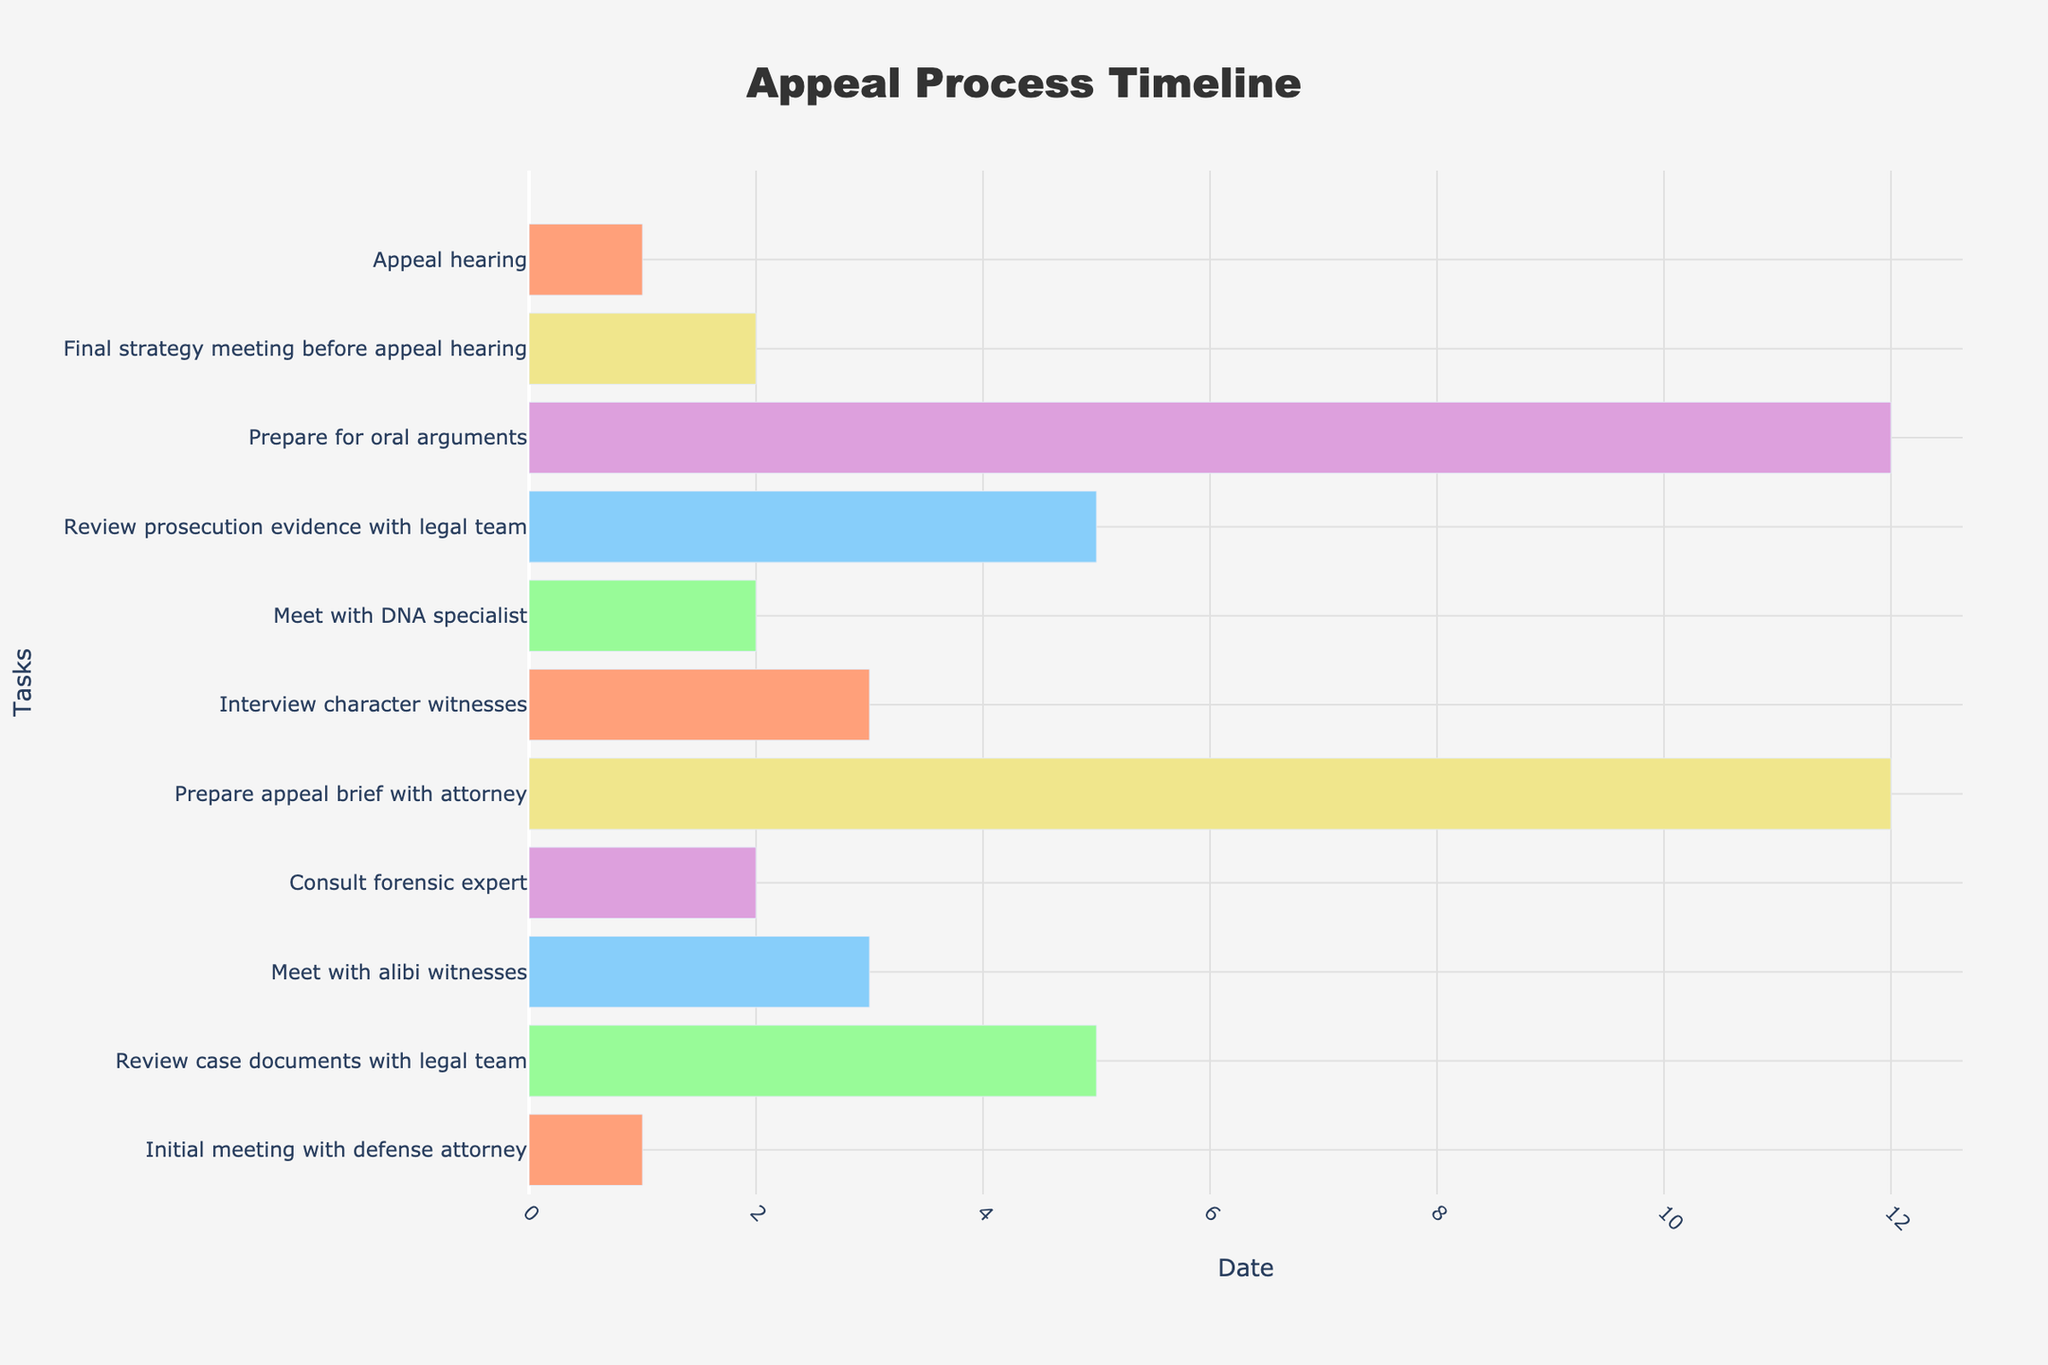What is the title of the Gantt Chart? The title can be found at the top of the figure. It is written in large, bold font.
Answer: Appeal Process Timeline Which task lasts the longest in duration? Look for the longest bar horizontally and check the labels. The task with the longest bar represents the longest duration.
Answer: Prepare appeal brief with attorney How many days did "Consult forensic expert" take? Locate the bar for "Consult forensic expert" and read the duration either from the hover text or by counting the days from start to end dates.
Answer: 2 days Which task finishes closest to the date of the appeal hearing? Check the end dates of all tasks and compare them to the appeal hearing date (2023-08-28). The task with the end date closest to 2023-08-28 is the answer.
Answer: Final strategy meeting before appeal hearing Between "Review prosecution evidence with legal team" and "Prepare for oral arguments", which one has a longer duration? Compare the lengths of the bars corresponding to these tasks. The task with the longer bar has a longer duration.
Answer: Prepare for oral arguments During which month does the "Interview character witnesses" task take place? Look at the start and end dates for the "Interview character witnesses" task. Identify the month in which these dates fall.
Answer: July How many tasks extend into July? Observe the start and end dates of all tasks and count how many tasks have dates that fall within July.
Answer: 4 Are any tasks scheduled during weekends? Find the rectangles representing weekends (light grey bars) and check if any task bars overlap with these rectangles.
Answer: No What is the total duration from the first task to the final task? Calculate the difference between the start date of the first task and the end date of the last task.
Answer: 89 days How many tasks are scheduled after "Prepare appeal brief with attorney"? Count the bars that are scheduled after the end date of "Prepare appeal brief with attorney".
Answer: 5 